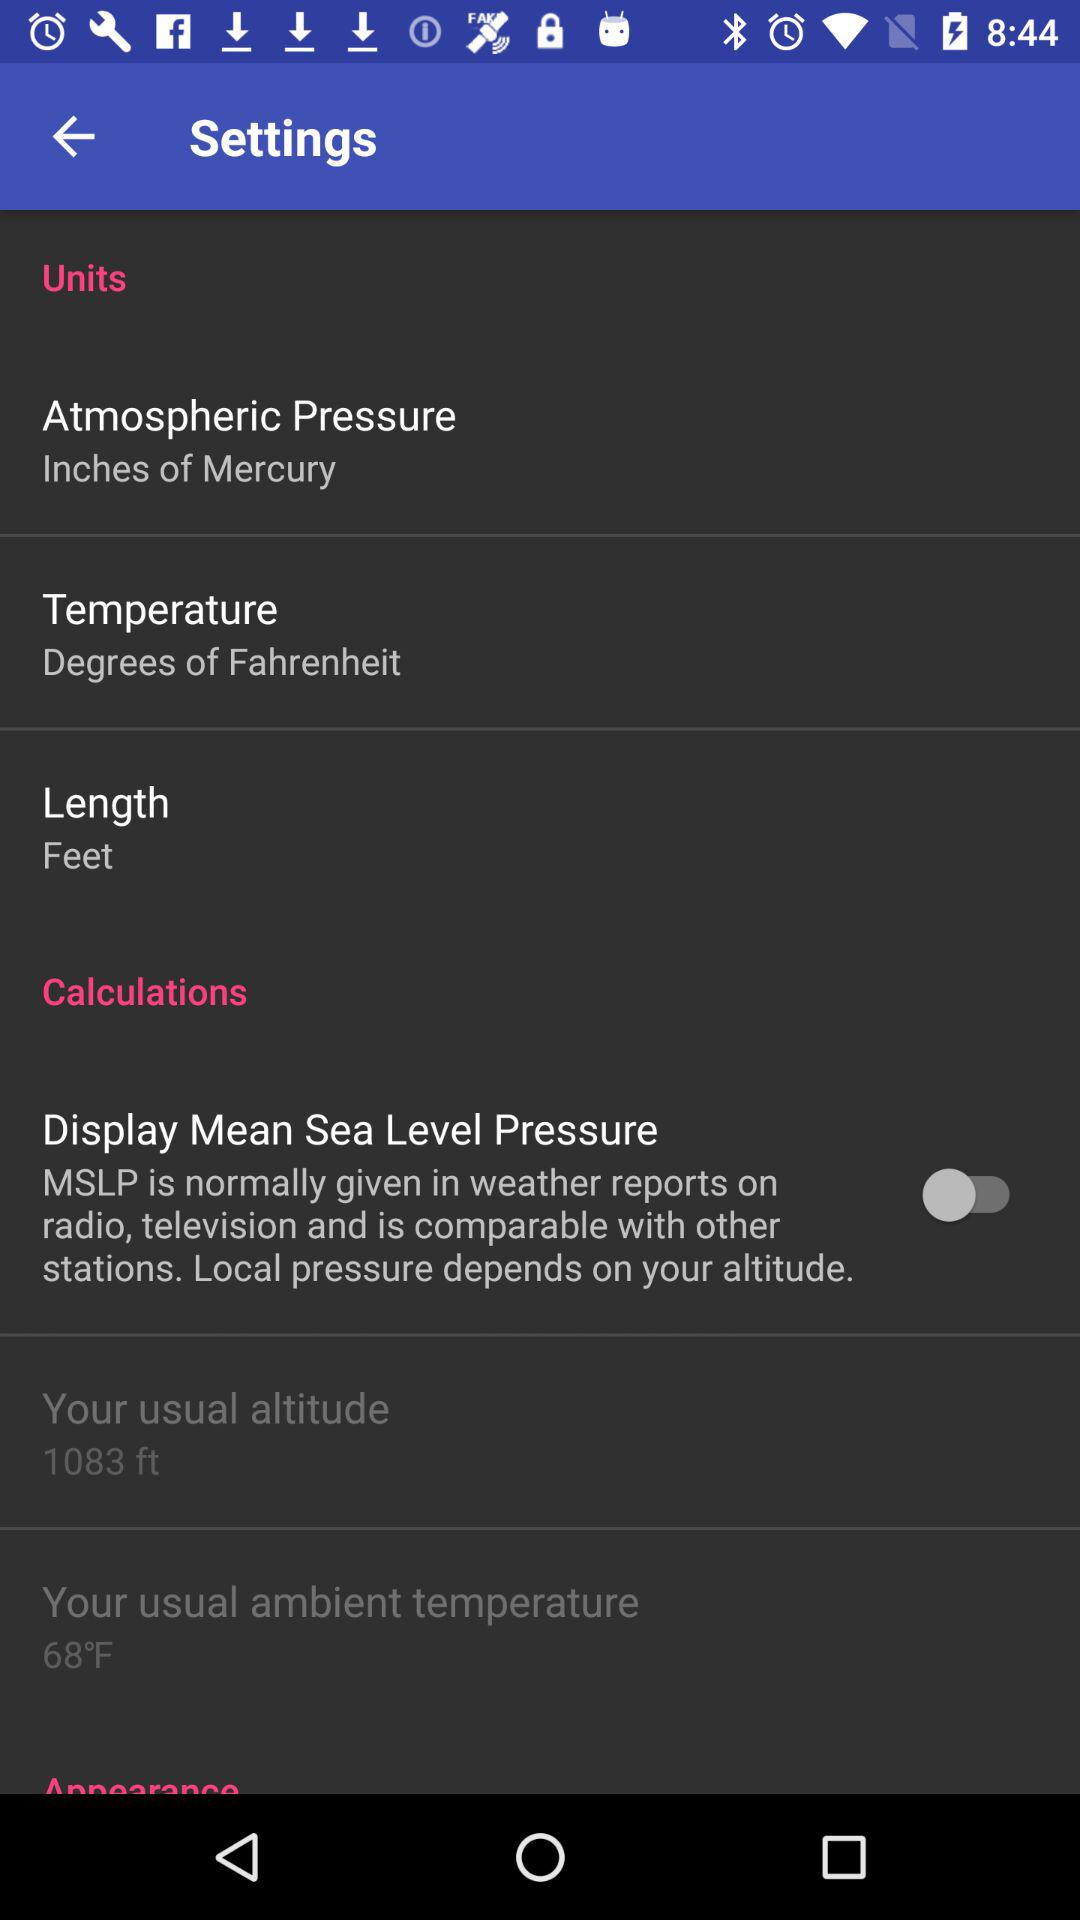What's the unit of temperature? The unit of temperature is degrees of fahrenheit. 